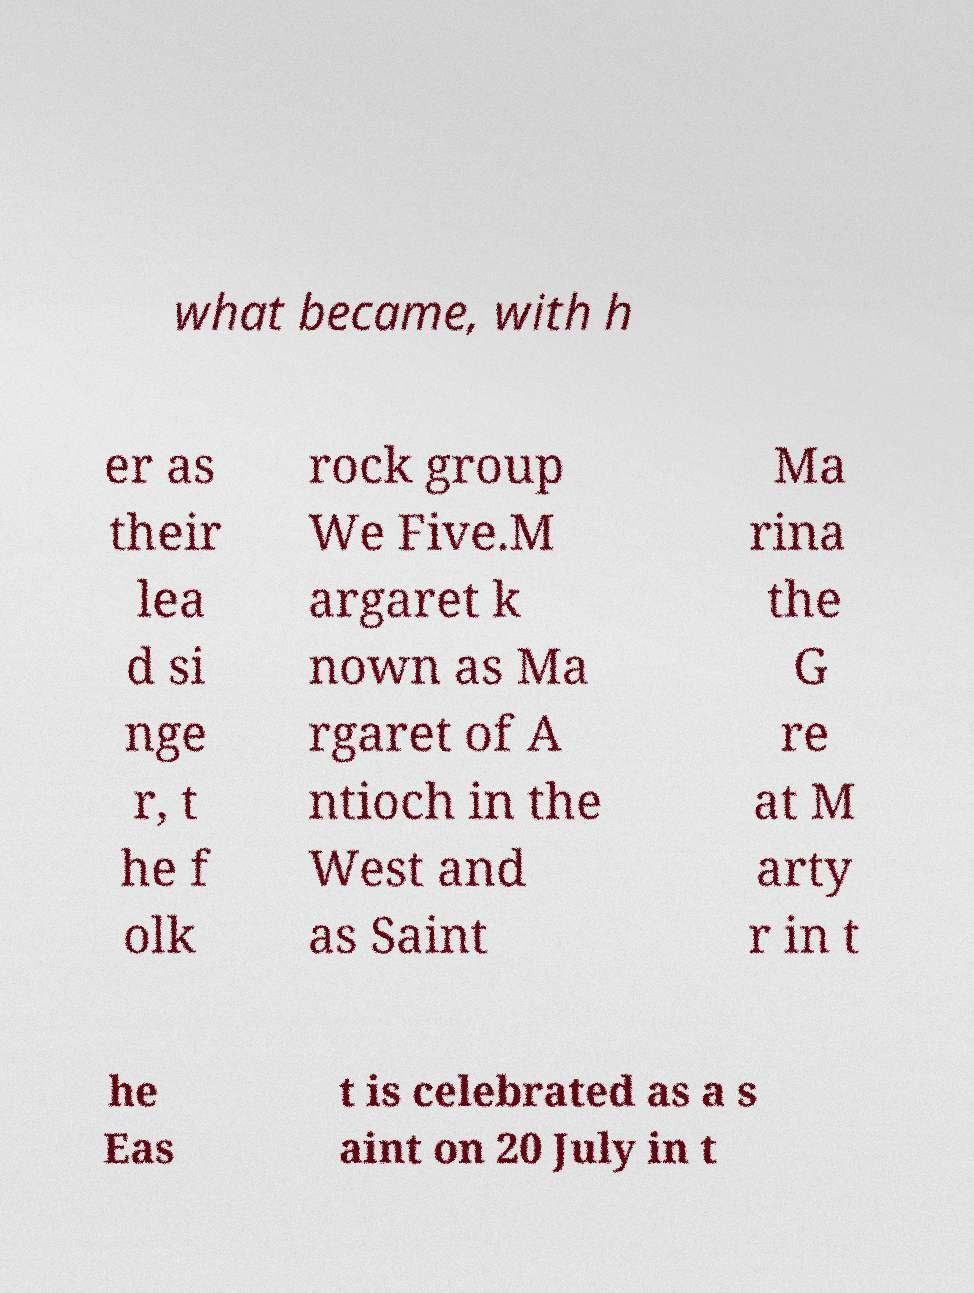Could you extract and type out the text from this image? what became, with h er as their lea d si nge r, t he f olk rock group We Five.M argaret k nown as Ma rgaret of A ntioch in the West and as Saint Ma rina the G re at M arty r in t he Eas t is celebrated as a s aint on 20 July in t 